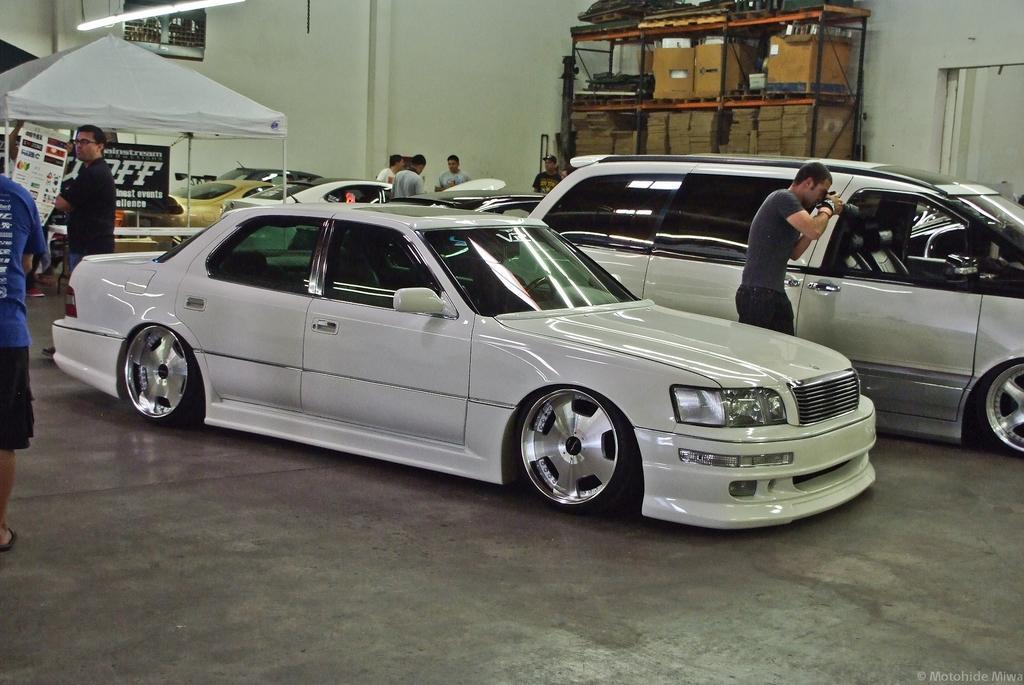Could you give a brief overview of what you see in this image? In this image we can see there are cars and there are people around them, one among them is taking a photo, on the top left corner of the image there is a tent, a light and posters with some text, behind it there are a few other objects, at the top right corner of the image there are rocks which contain some objects in it. 